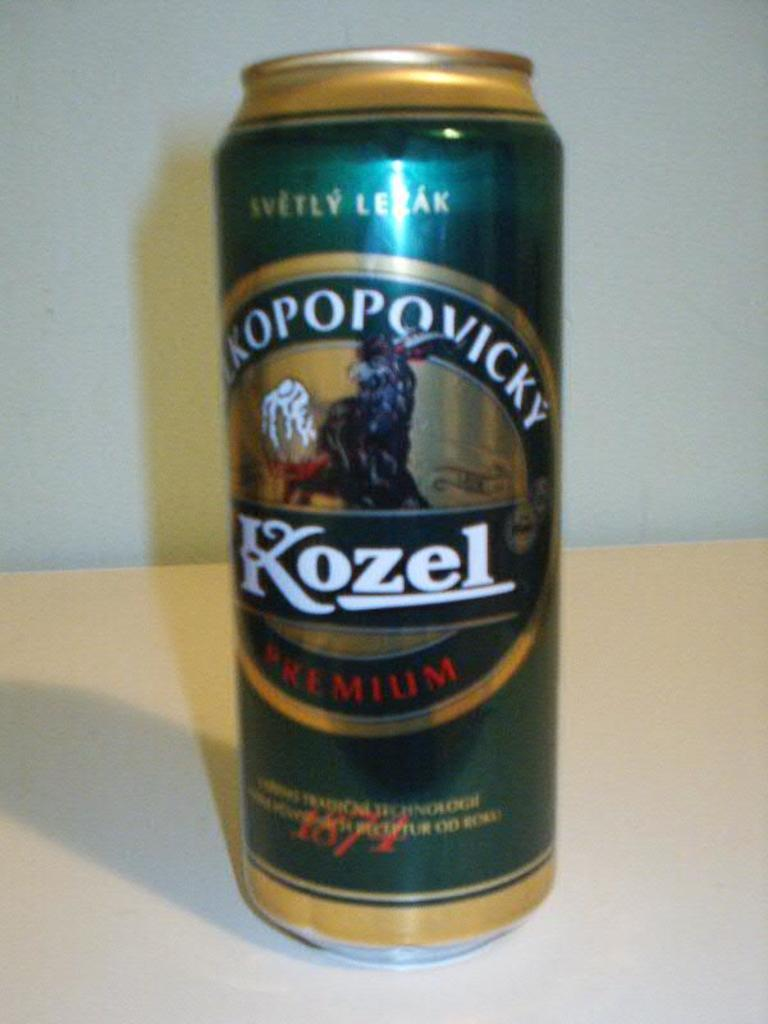<image>
Render a clear and concise summary of the photo. a large can of Kozel Premium alcohol. 